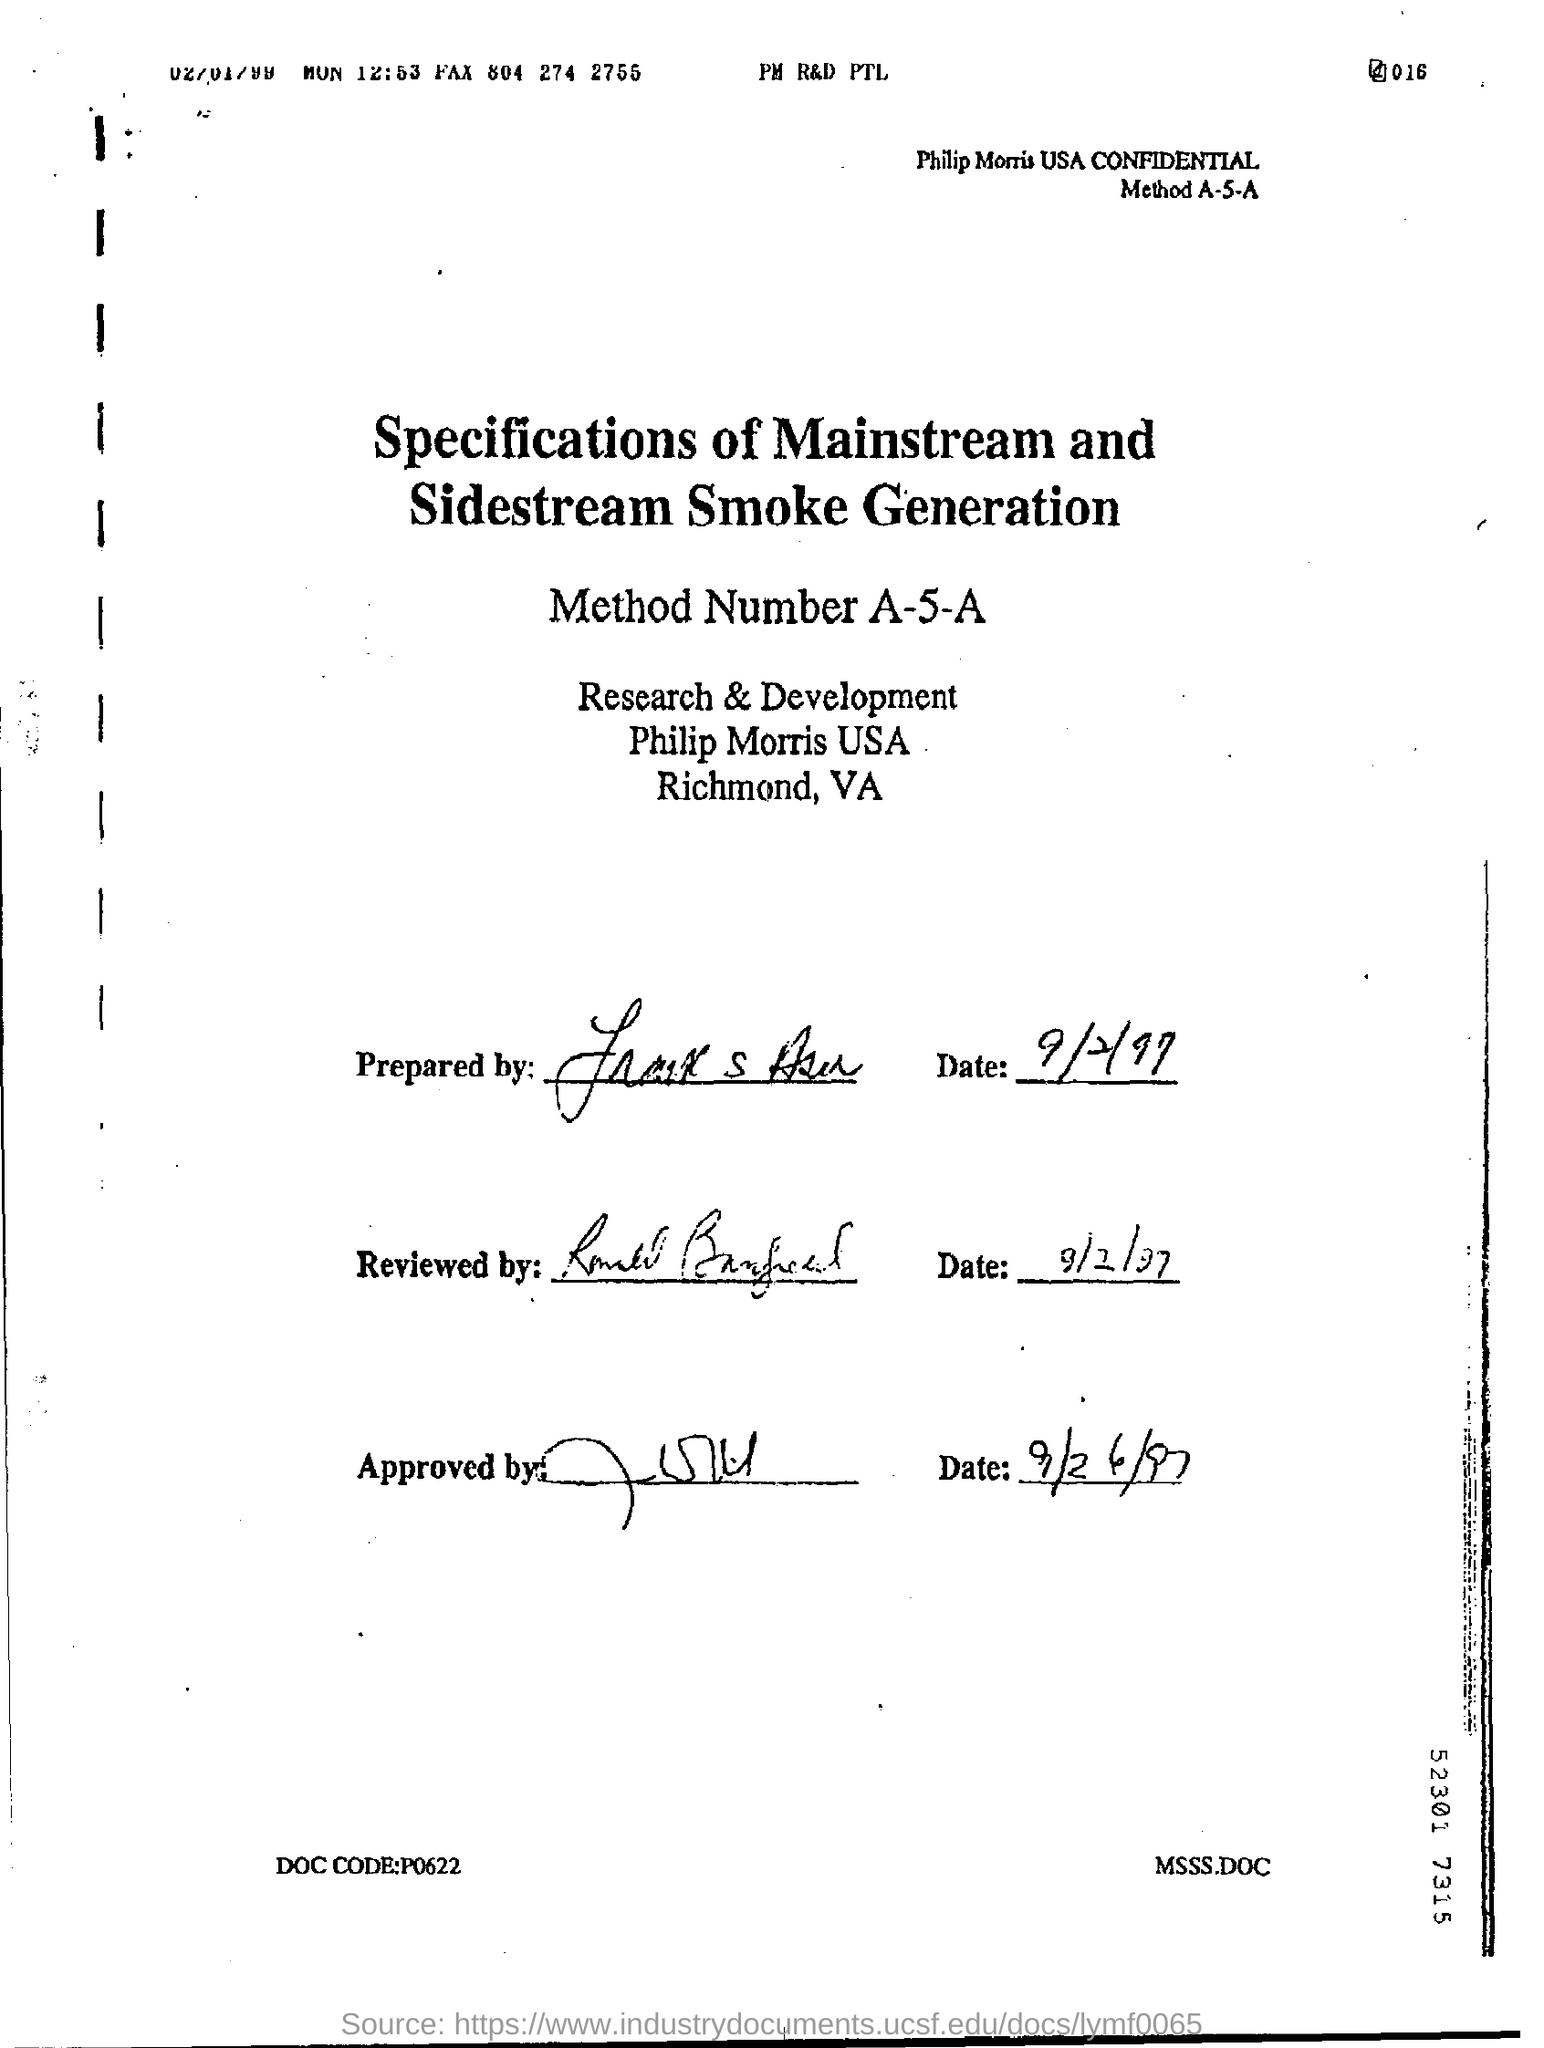Give some essential details in this illustration. The method number mentioned on the page is A-5-A. The letter was reviewed on September 2, 1997. 